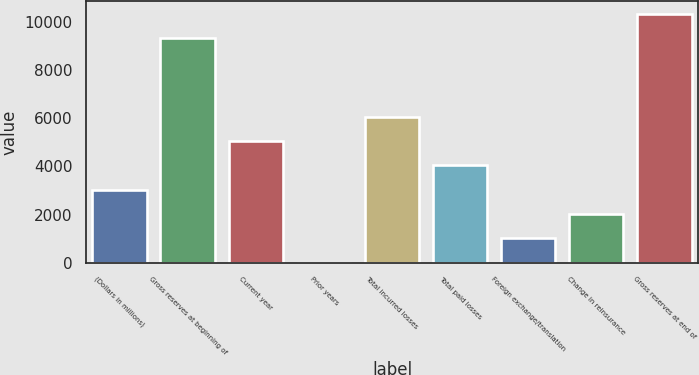Convert chart to OTSL. <chart><loc_0><loc_0><loc_500><loc_500><bar_chart><fcel>(Dollars in millions)<fcel>Gross reserves at beginning of<fcel>Current year<fcel>Prior years<fcel>Total incurred losses<fcel>Total paid losses<fcel>Foreign exchange/translation<fcel>Change in reinsurance<fcel>Gross reserves at end of<nl><fcel>3039.55<fcel>9340.2<fcel>5063.45<fcel>3.7<fcel>6075.4<fcel>4051.5<fcel>1015.65<fcel>2027.6<fcel>10352.1<nl></chart> 